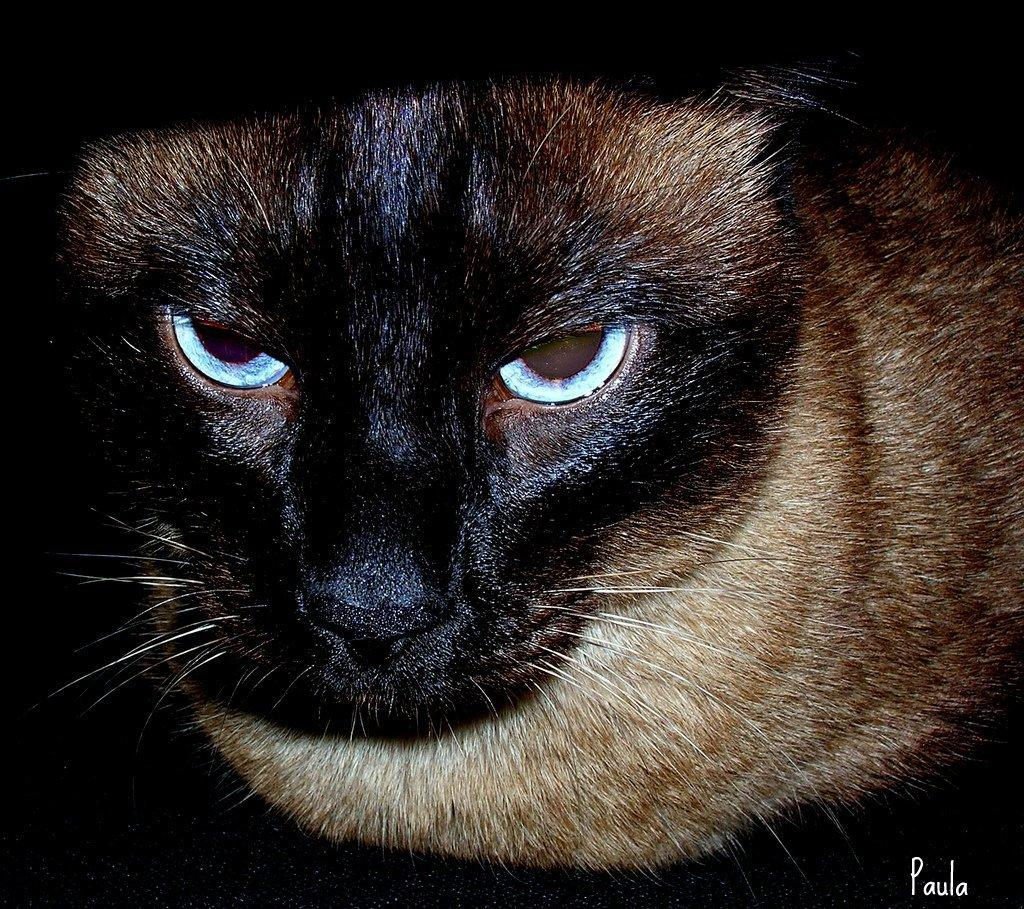What type of animal is in the image? There is a cat in the image. Can you describe anything else visible in the image? There is some text on the right side of the image. What time is displayed on the clock in the image? There is no clock present in the image, so it is not possible to determine the time. 